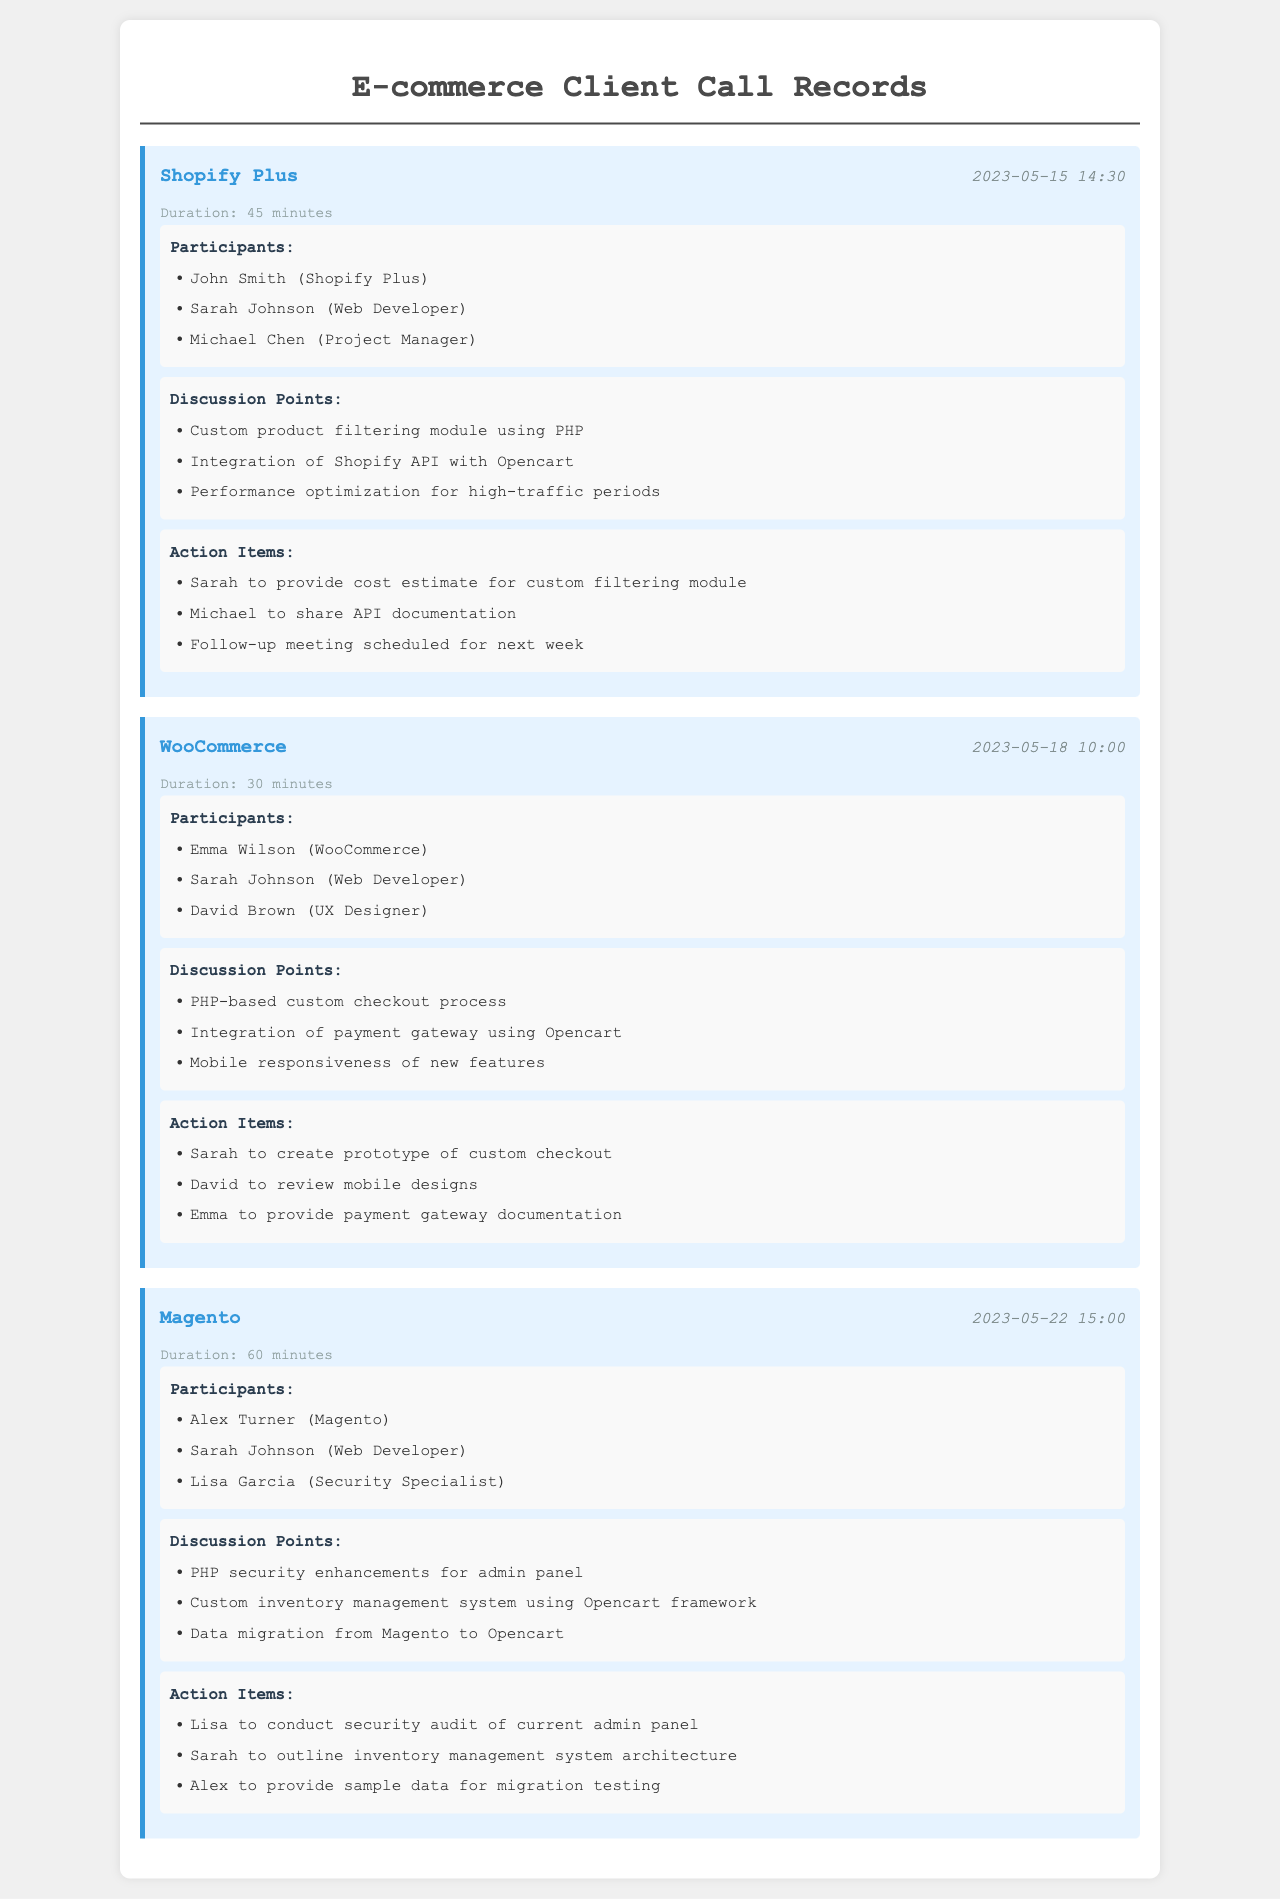What is the date of the call with Shopify Plus? The date of the call is mentioned in the call header as "2023-05-15".
Answer: 2023-05-15 Who is the project manager in the call with Shopify Plus? The participants section lists "Michael Chen" as the project manager.
Answer: Michael Chen How long was the call with WooCommerce? The duration of the call is noted as "30 minutes".
Answer: 30 minutes What is one of the discussion points from the call with Magento? The discussion points include "PHP security enhancements for admin panel".
Answer: PHP security enhancements for admin panel Who is responsible for reviewing mobile designs after the call with WooCommerce? The action items specify that "David" is tasked with reviewing mobile designs.
Answer: David How many minutes did the conference call with Magento last? The duration of the call is stated as "60 minutes".
Answer: 60 minutes What action item is assigned to Sarah after the call with Shopify Plus? The action items state that "Sarah to provide cost estimate for custom filtering module".
Answer: Sarah to provide cost estimate for custom filtering module Which e-commerce client was discussed last in the records? The last call record is for "Magento".
Answer: Magento Who participated in the call with WooCommerce? The participants listed include "Emma Wilson (WooCommerce)", "Sarah Johnson (Web Developer)", and "David Brown (UX Designer)".
Answer: Emma Wilson (WooCommerce), Sarah Johnson (Web Developer), David Brown (UX Designer) 